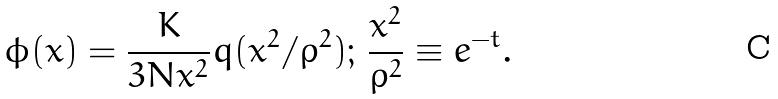<formula> <loc_0><loc_0><loc_500><loc_500>\phi ( x ) = \frac { K } { 3 N x ^ { 2 } } q ( x ^ { 2 } / \rho ^ { 2 } ) ; \, \frac { x ^ { 2 } } { \rho ^ { 2 } } \equiv e ^ { - t } .</formula> 